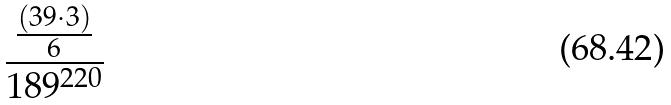Convert formula to latex. <formula><loc_0><loc_0><loc_500><loc_500>\frac { \frac { ( 3 9 \cdot 3 ) } { 6 } } { 1 8 9 ^ { 2 2 0 } }</formula> 